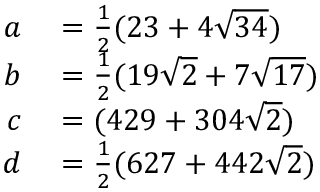Convert formula to latex. <formula><loc_0><loc_0><loc_500><loc_500>\begin{array} { r l } { a } & = { \frac { 1 } { 2 } } ( 2 3 + 4 { \sqrt { 3 4 } } ) } \\ { b } & = { \frac { 1 } { 2 } } ( 1 9 { \sqrt { 2 } } + 7 { \sqrt { 1 7 } } ) } \\ { c } & = ( 4 2 9 + 3 0 4 { \sqrt { 2 } } ) } \\ { d } & = { \frac { 1 } { 2 } } ( 6 2 7 + 4 4 2 { \sqrt { 2 } } ) } \end{array}</formula> 